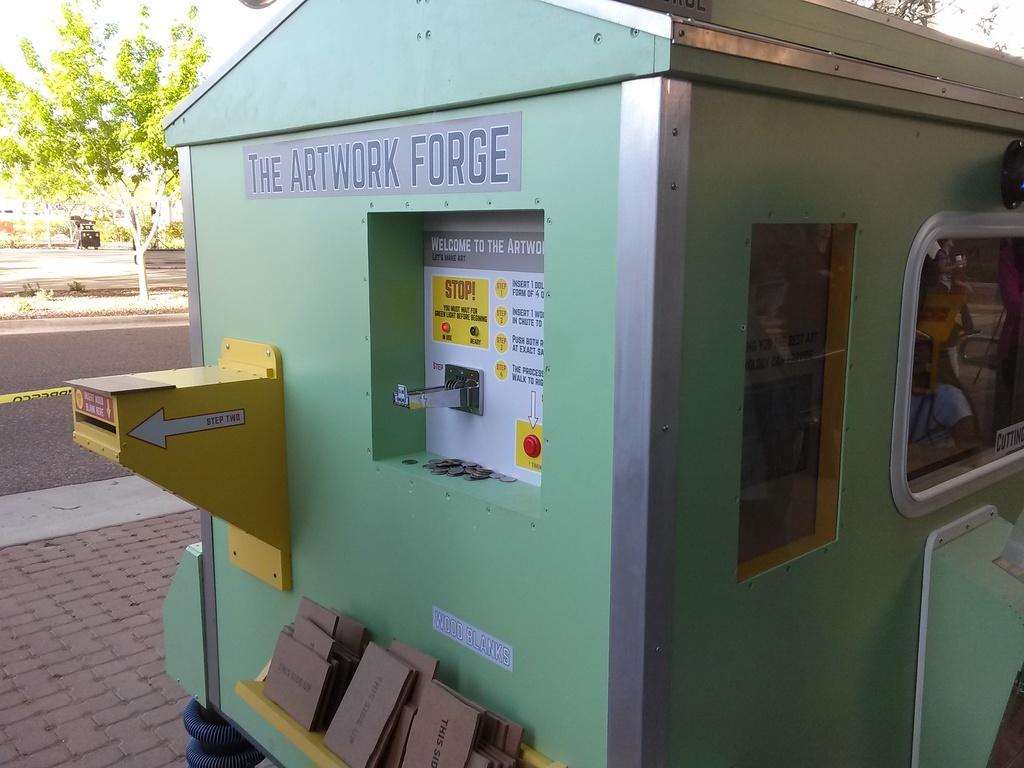<image>
Summarize the visual content of the image. The Artwork Forge that is located outside in daytime 